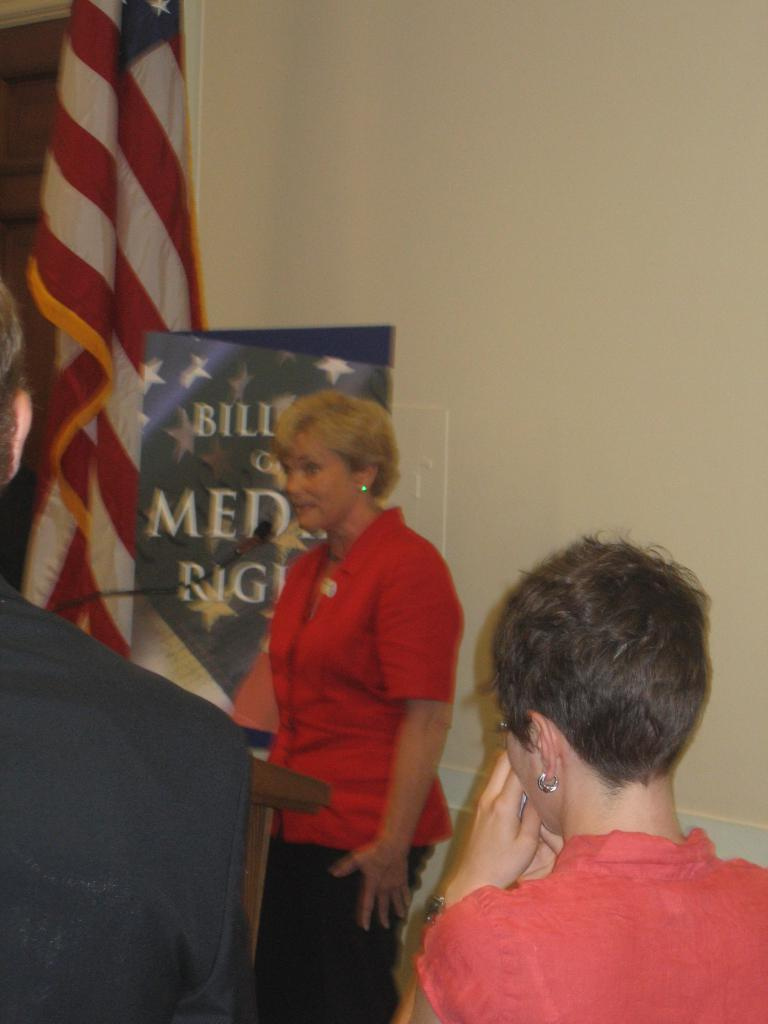What can be seen in the image involving people? There are people standing in the image. What object is present that might be used for amplifying sound? There is a microphone in the image. What national symbol is visible in the image? There is a flag in the image. What type of structure can be seen in the background? There is a wall in the image. What type of printed material is present in the image? There is a poster in the image. What color are the ants crawling on the microphone in the image? There are no ants present in the image, so we cannot determine their color. What advice does the father give to the people in the image? There is no father present in the image, so we cannot determine the advice given. 